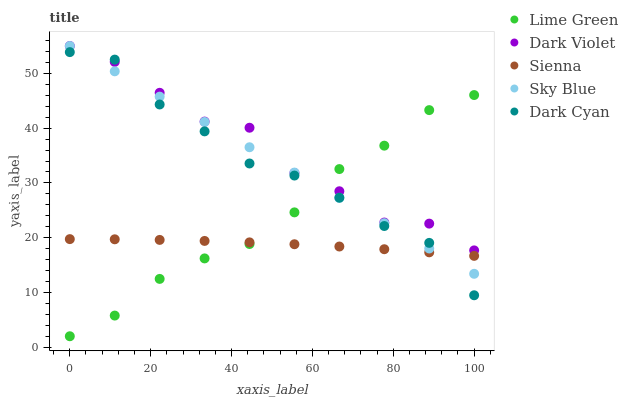Does Sienna have the minimum area under the curve?
Answer yes or no. Yes. Does Dark Violet have the maximum area under the curve?
Answer yes or no. Yes. Does Sky Blue have the minimum area under the curve?
Answer yes or no. No. Does Sky Blue have the maximum area under the curve?
Answer yes or no. No. Is Sky Blue the smoothest?
Answer yes or no. Yes. Is Dark Violet the roughest?
Answer yes or no. Yes. Is Lime Green the smoothest?
Answer yes or no. No. Is Lime Green the roughest?
Answer yes or no. No. Does Lime Green have the lowest value?
Answer yes or no. Yes. Does Sky Blue have the lowest value?
Answer yes or no. No. Does Dark Violet have the highest value?
Answer yes or no. Yes. Does Lime Green have the highest value?
Answer yes or no. No. Is Sienna less than Dark Violet?
Answer yes or no. Yes. Is Dark Violet greater than Sienna?
Answer yes or no. Yes. Does Sienna intersect Dark Cyan?
Answer yes or no. Yes. Is Sienna less than Dark Cyan?
Answer yes or no. No. Is Sienna greater than Dark Cyan?
Answer yes or no. No. Does Sienna intersect Dark Violet?
Answer yes or no. No. 